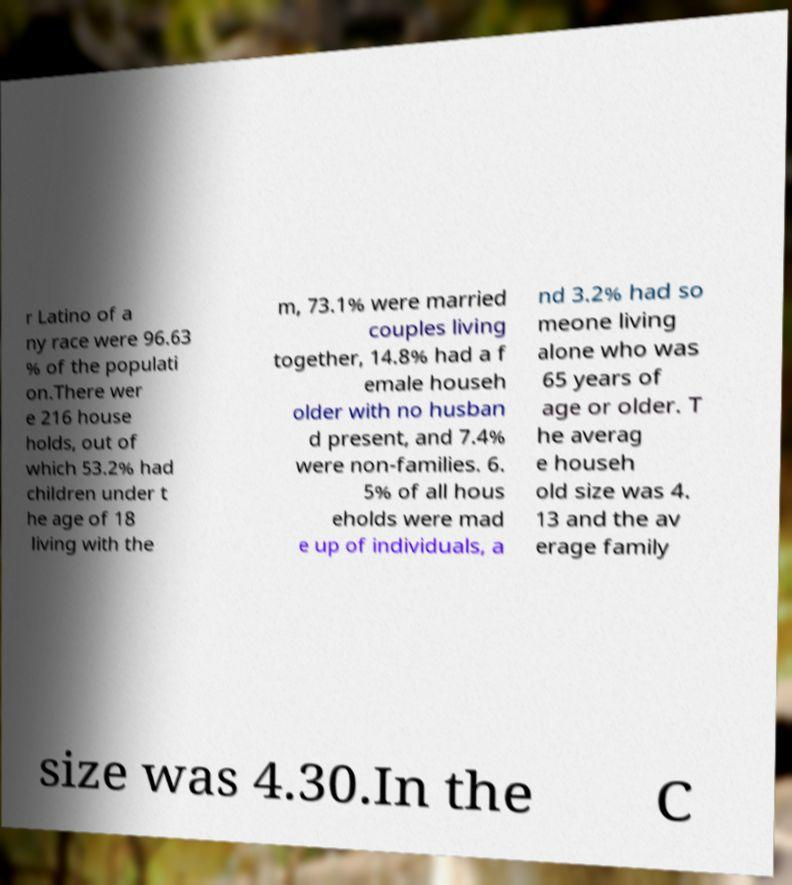There's text embedded in this image that I need extracted. Can you transcribe it verbatim? r Latino of a ny race were 96.63 % of the populati on.There wer e 216 house holds, out of which 53.2% had children under t he age of 18 living with the m, 73.1% were married couples living together, 14.8% had a f emale househ older with no husban d present, and 7.4% were non-families. 6. 5% of all hous eholds were mad e up of individuals, a nd 3.2% had so meone living alone who was 65 years of age or older. T he averag e househ old size was 4. 13 and the av erage family size was 4.30.In the C 